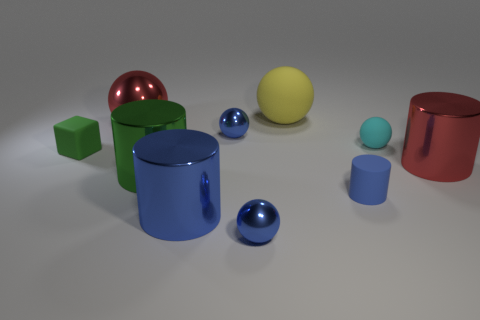Subtract all blue spheres. How many spheres are left? 3 Subtract all blue spheres. How many spheres are left? 3 Subtract all cubes. How many objects are left? 9 Subtract 3 spheres. How many spheres are left? 2 Subtract all yellow balls. Subtract all purple blocks. How many balls are left? 4 Subtract all yellow cylinders. How many blue cubes are left? 0 Subtract all big cyan things. Subtract all tiny blue metal objects. How many objects are left? 8 Add 1 small cyan balls. How many small cyan balls are left? 2 Add 4 blue matte cylinders. How many blue matte cylinders exist? 5 Subtract 0 purple spheres. How many objects are left? 10 